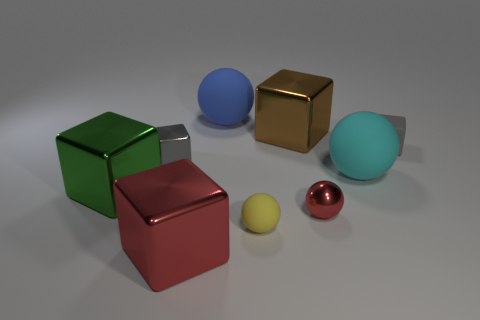Are there more green shiny blocks that are in front of the tiny red shiny ball than small gray rubber objects?
Give a very brief answer. No. How many tiny cubes are to the left of the big rubber sphere that is left of the large shiny object that is behind the green metal block?
Provide a succinct answer. 1. There is a small gray object that is in front of the rubber cube; does it have the same shape as the small yellow rubber object?
Offer a terse response. No. What is the material of the tiny block that is right of the big blue thing?
Your response must be concise. Rubber. What is the shape of the object that is both behind the gray shiny object and on the right side of the small metal sphere?
Provide a short and direct response. Cube. What material is the big cyan sphere?
Your answer should be compact. Rubber. What number of cubes are gray metal objects or large things?
Ensure brevity in your answer.  4. Do the brown cube and the big red thing have the same material?
Provide a short and direct response. Yes. There is a blue matte object that is the same shape as the yellow matte thing; what size is it?
Your answer should be very brief. Large. What is the material of the big cube that is both behind the tiny yellow matte sphere and to the left of the large blue matte object?
Your answer should be compact. Metal. 